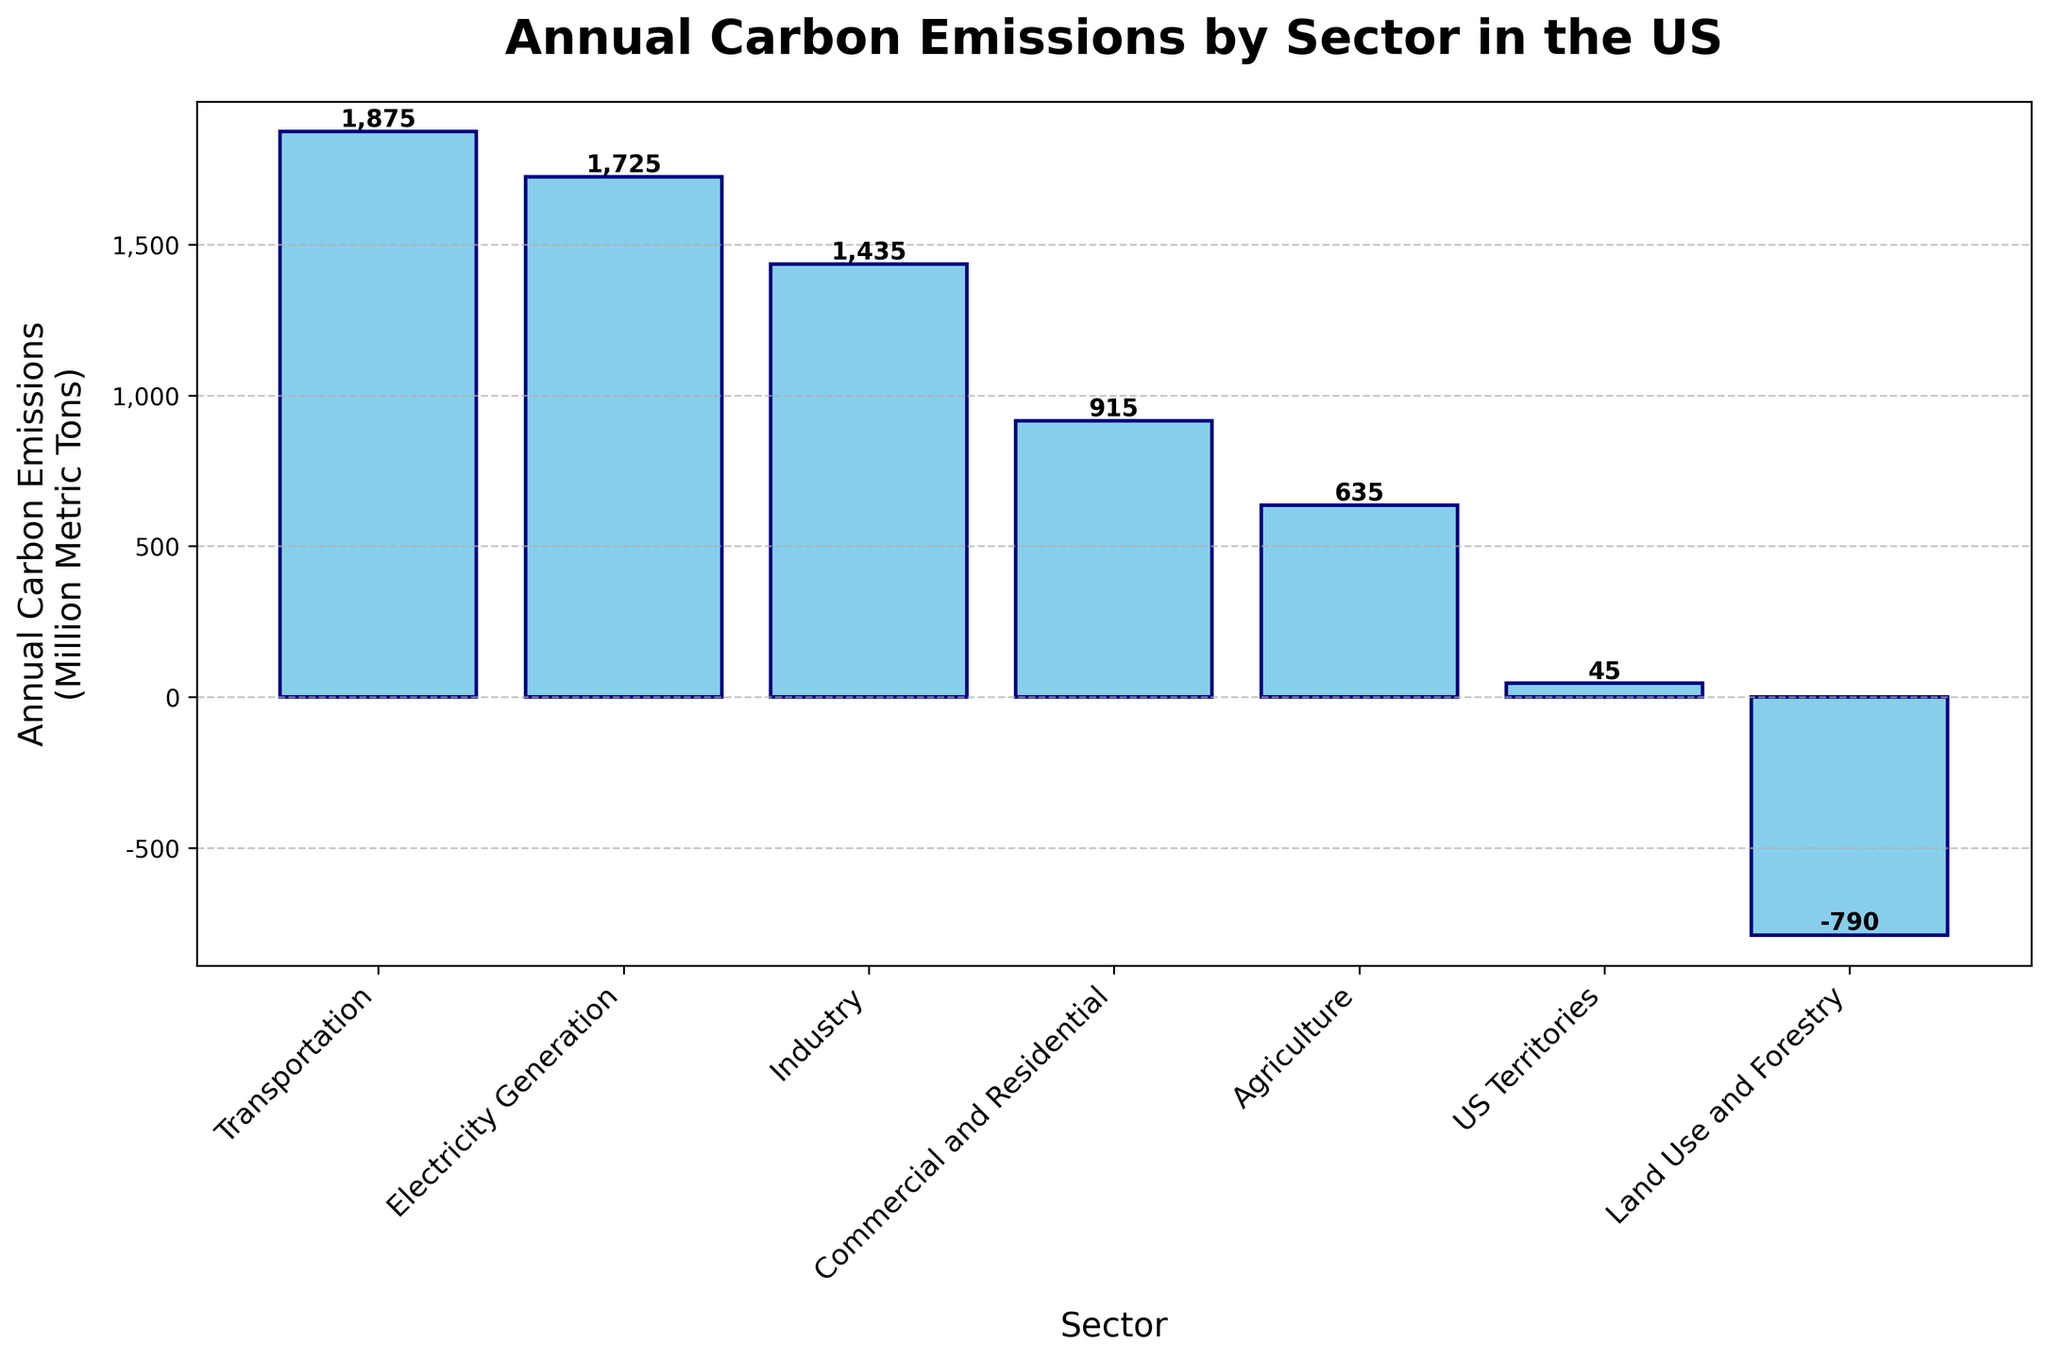Which sector has the highest carbon emissions? The figure shows bars of different heights representing annual carbon emissions per sector. The tallest bar corresponds to the maximum value.
Answer: Transportation What is the approximate difference in emissions between Transportation and Electricity Generation? The height of the bar for Transportation is 1875, and for Electricity Generation, it is 1725. Subtracting these two values, 1875 - 1725 = 150.
Answer: 150 Which sectors have carbon emissions greater than 1000 million metric tons? By looking at the bars with heights surpassing 1000 units, the sectors are Transportation, Electricity Generation, and Industry.
Answer: Transportation, Electricity Generation, Industry What is the total carbon emission from all sectors except Land Use and Forestry? Sum the emissions values for all sectors except Land Use and Forestry: 1875 (Transportation) + 1725 (Electricity Generation) + 1435 (Industry) + 915 (Commercial and Residential) + 635 (Agriculture) + 45 (US Territories) = 6630.
Answer: 6630 How do Transportation and Agriculture compare in terms of carbon emissions visually? The bar for Transportation is significantly taller than the bar for Agriculture, indicating that Transportation's emissions are much higher.
Answer: Transportation's emissions are much higher What is the median value of the carbon emissions across all sectors? To find the median, list all the values in order and find the middle value. The ordered values are: -790, 45, 635, 915, 1435, 1725, 1875. The middle value, being the fourth one, is 915.
Answer: 915 What is the visual representation of negative carbon emissions in the chart? The negative carbon emission for Land Use and Forestry is shown by a bar extending below the horizontal axis.
Answer: A bar extending below the axis What is the average carbon emission of the sectors excluding Land Use and Forestry? To find the average, sum all the emission values excluding Land Use and Forestry, which is 6630, then divide by the number of sectors (6): 6630 / 6 = 1105.
Answer: 1105 What is the combined carbon emission of Industry and Commercial and Residential sectors? Sum of emissions from Industry (1435) and Commercial and Residential (915) = 1435 + 915 = 2350.
Answer: 2350 How does the carbon emission of US Territories compare with Agriculture? The bar for US Territories is much shorter in height compared to the bar for Agriculture, indicating much lower emissions.
Answer: Much lower 